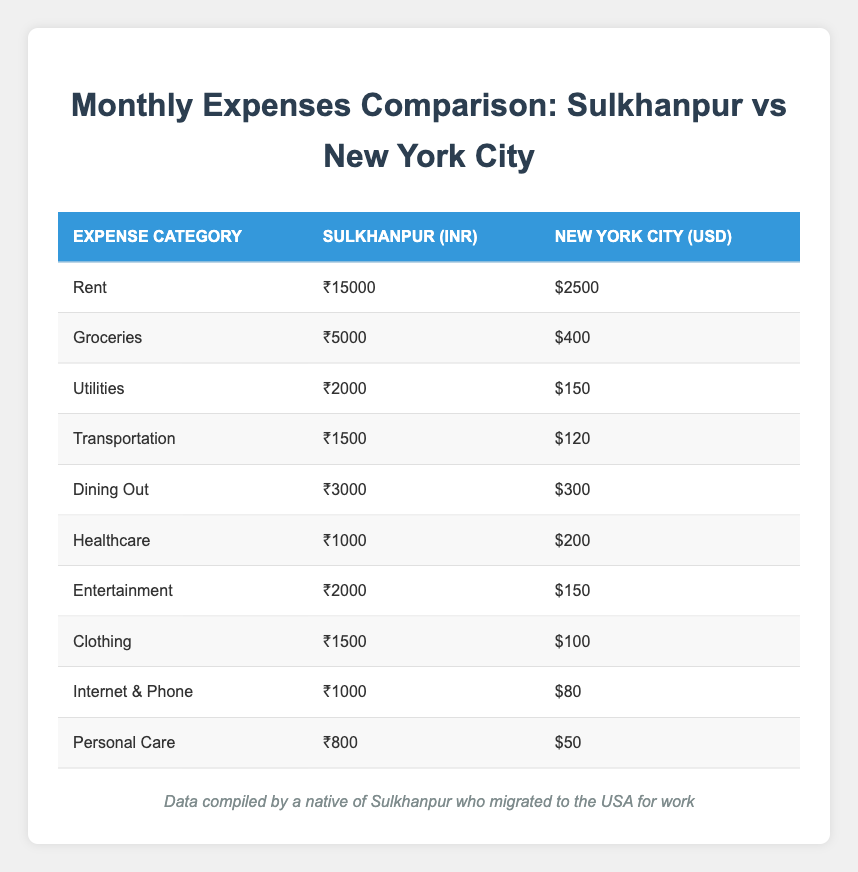What is the total rent expense in Sulkhanpur? The rent expense for Sulkhanpur is given in the table as 15000 INR.
Answer: 15000 How much is the dining out expense in New York City? The dining out expense for New York City is shown in the table as 300 USD.
Answer: 300 Which expense category is the most expensive in Sulkhanpur? By comparing the expenses listed, rent (15000 INR) is the highest expense category compared to others.
Answer: Rent What is the total healthcare and personal care expense in New York City? The healthcare expense is 200 USD and personal care is 50 USD. Adding them together: 200 + 50 = 250 USD.
Answer: 250 Is the transportation expense lower in Sulkhanpur than in New York City? The transportation expense for Sulkhanpur is 1500 INR, while for New York City it is 120 USD. A direct comparison shows that 1500 INR is higher than 120 USD when considering current currency values.
Answer: Yes What is the average monthly expense for utilities in both locations? The utility expense for Sulkhanpur is 2000 INR and for New York City, it is 150 USD. To find the average, we first convert everything to one currency. Assuming 1 USD = 75 INR, 150 USD converts to 11250 INR. Therefore, the average is (2000 + 11250) / 2 = 6637.5 INR.
Answer: 6637.5 Which category has the least expense in Sulkhanpur? By examining the table, personal care has the least expense at 800 INR in Sulkhanpur.
Answer: Personal Care If we sum all expenses in New York City, what is the total? To find the total expenses for New York City, we add all values: 2500 + 400 + 150 + 120 + 300 + 200 + 150 + 100 + 80 + 50 = 4050 USD.
Answer: 4050 Are dining out expenses in Sulkhanpur higher than in New York City? The dining out expense in Sulkhanpur is 3000 INR, while in New York City it is 300 USD. Converting 300 USD to INR (300 * 75 = 22500), we see that 3000 INR is significantly lower than 22500 INR.
Answer: No 